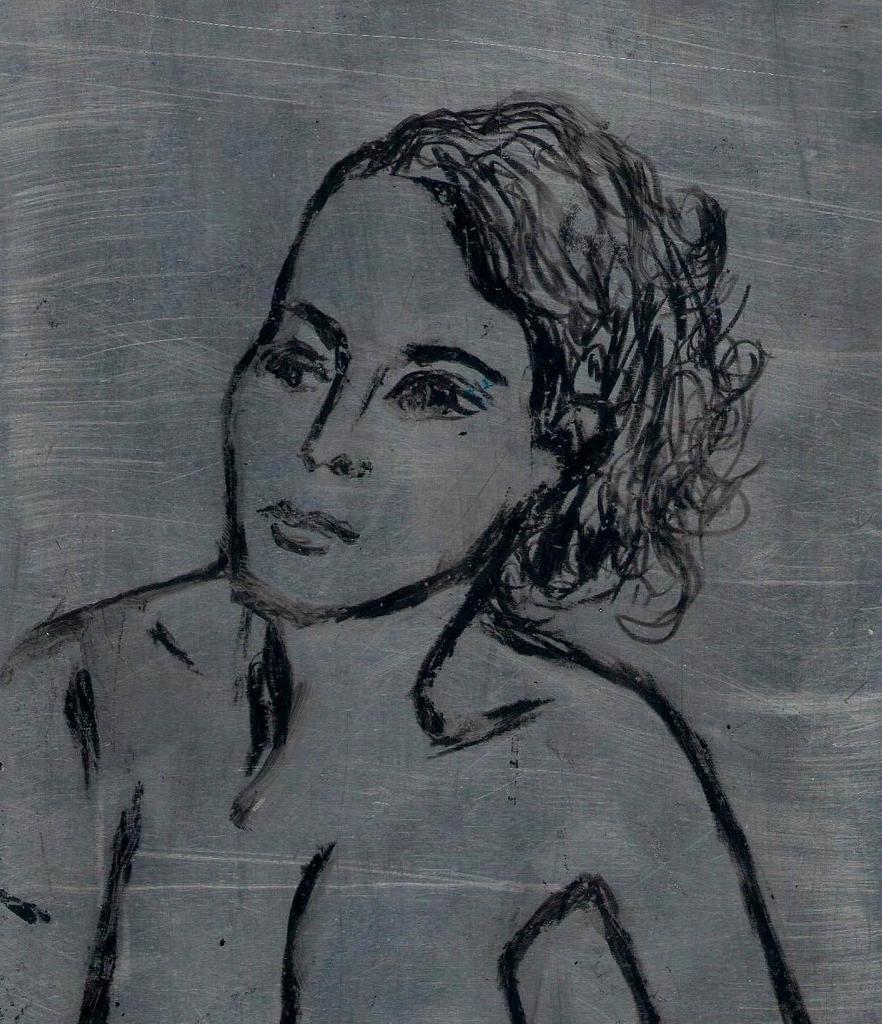In one or two sentences, can you explain what this image depicts? In this image there is a sketch of a person. 